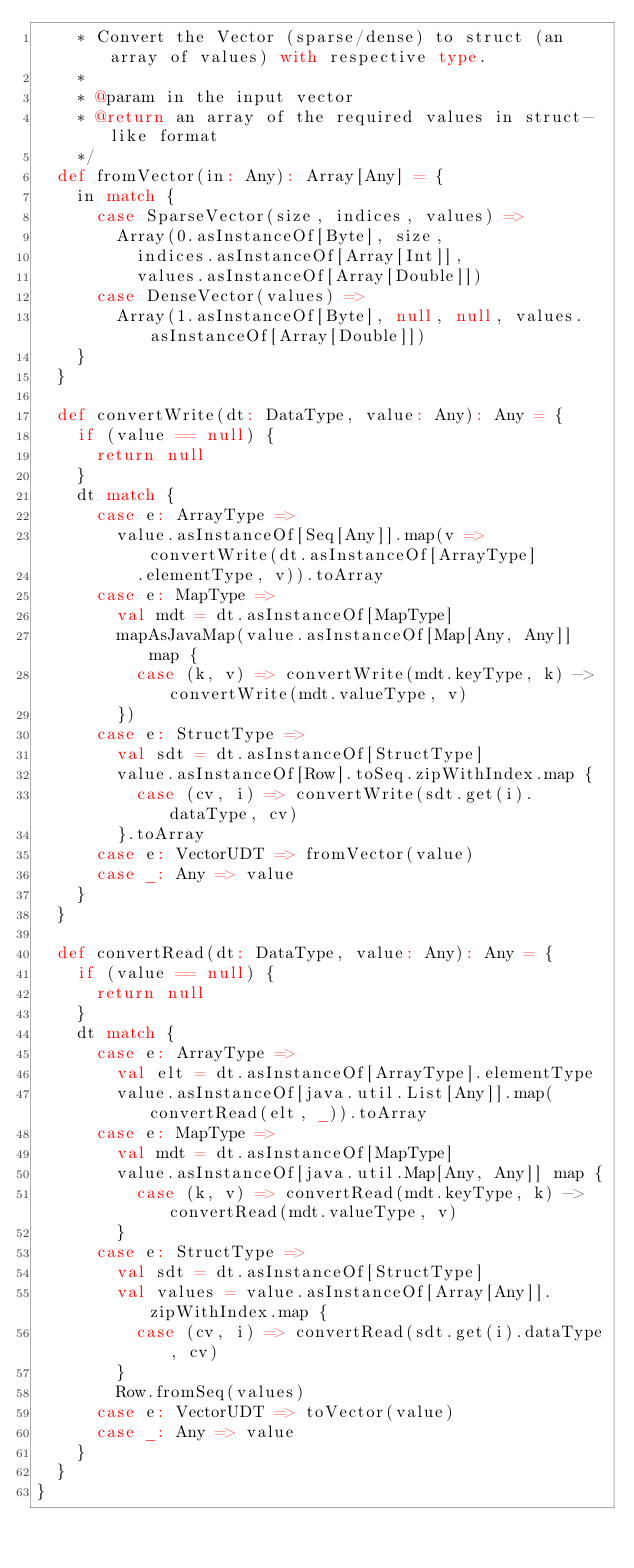<code> <loc_0><loc_0><loc_500><loc_500><_Scala_>    * Convert the Vector (sparse/dense) to struct (an array of values) with respective type.
    *
    * @param in the input vector
    * @return an array of the required values in struct-like format
    */
  def fromVector(in: Any): Array[Any] = {
    in match {
      case SparseVector(size, indices, values) =>
        Array(0.asInstanceOf[Byte], size,
          indices.asInstanceOf[Array[Int]],
          values.asInstanceOf[Array[Double]])
      case DenseVector(values) =>
        Array(1.asInstanceOf[Byte], null, null, values.asInstanceOf[Array[Double]])
    }
  }

  def convertWrite(dt: DataType, value: Any): Any = {
    if (value == null) {
      return null
    }
    dt match {
      case e: ArrayType =>
        value.asInstanceOf[Seq[Any]].map(v => convertWrite(dt.asInstanceOf[ArrayType]
          .elementType, v)).toArray
      case e: MapType =>
        val mdt = dt.asInstanceOf[MapType]
        mapAsJavaMap(value.asInstanceOf[Map[Any, Any]] map {
          case (k, v) => convertWrite(mdt.keyType, k) -> convertWrite(mdt.valueType, v)
        })
      case e: StructType =>
        val sdt = dt.asInstanceOf[StructType]
        value.asInstanceOf[Row].toSeq.zipWithIndex.map {
          case (cv, i) => convertWrite(sdt.get(i).dataType, cv)
        }.toArray
      case e: VectorUDT => fromVector(value)
      case _: Any => value
    }
  }

  def convertRead(dt: DataType, value: Any): Any = {
    if (value == null) {
      return null
    }
    dt match {
      case e: ArrayType =>
        val elt = dt.asInstanceOf[ArrayType].elementType
        value.asInstanceOf[java.util.List[Any]].map(convertRead(elt, _)).toArray
      case e: MapType =>
        val mdt = dt.asInstanceOf[MapType]
        value.asInstanceOf[java.util.Map[Any, Any]] map {
          case (k, v) => convertRead(mdt.keyType, k) -> convertRead(mdt.valueType, v)
        }
      case e: StructType =>
        val sdt = dt.asInstanceOf[StructType]
        val values = value.asInstanceOf[Array[Any]].zipWithIndex.map {
          case (cv, i) => convertRead(sdt.get(i).dataType, cv)
        }
        Row.fromSeq(values)
      case e: VectorUDT => toVector(value)
      case _: Any => value
    }
  }
}
</code> 